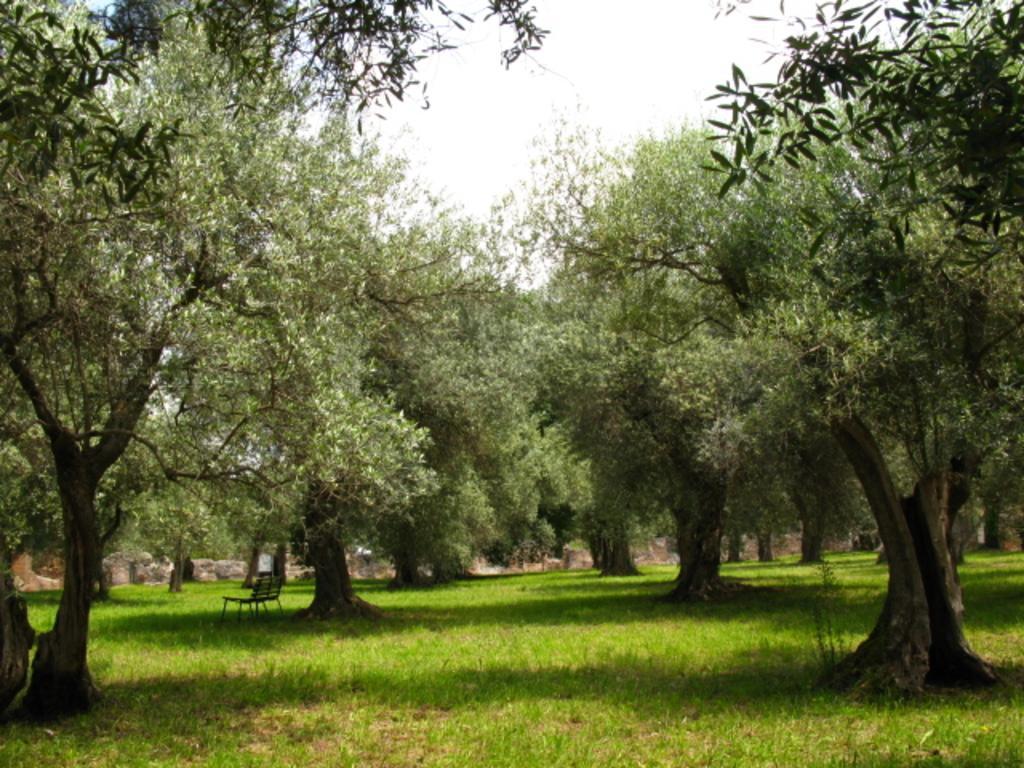In one or two sentences, can you explain what this image depicts? Here in this picture we can see a grass lawn with many huge trees. 